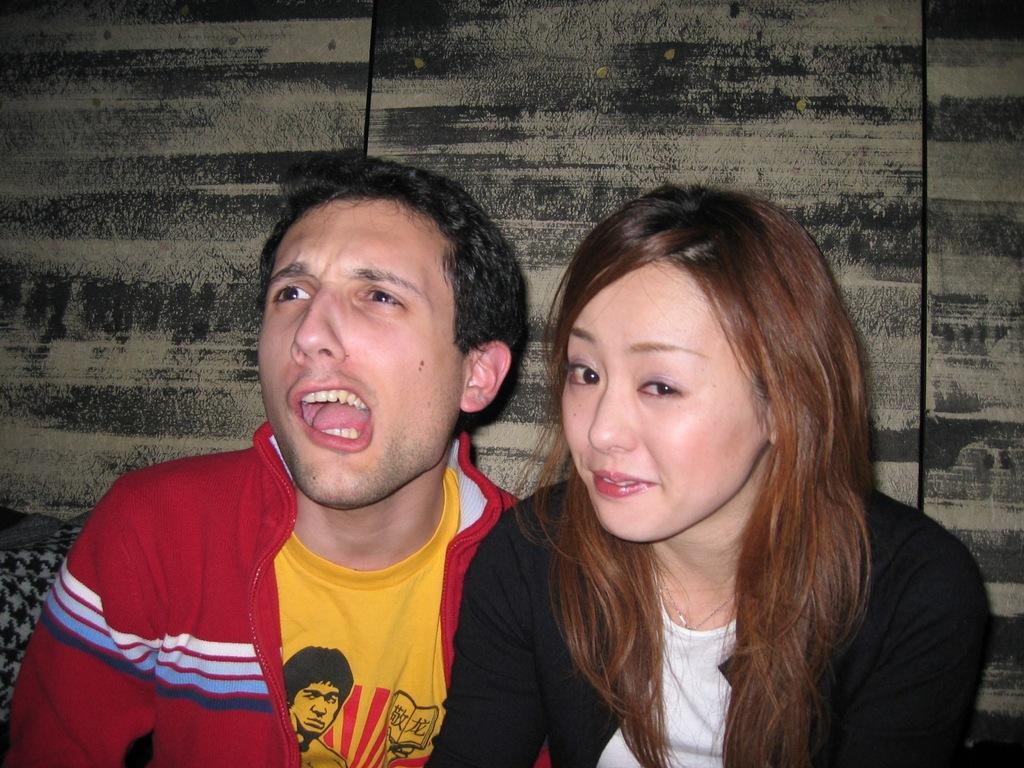Can you describe this image briefly? In this image, I can see the man and woman sitting. This looks like a wooden board. I think this is a cloth. 